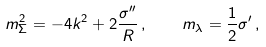Convert formula to latex. <formula><loc_0><loc_0><loc_500><loc_500>m ^ { 2 } _ { \Sigma } = - 4 k ^ { 2 } + 2 \frac { \sigma ^ { \prime \prime } } { R } \, , \quad m _ { \lambda } = \frac { 1 } { 2 } \sigma ^ { \prime } \, ,</formula> 